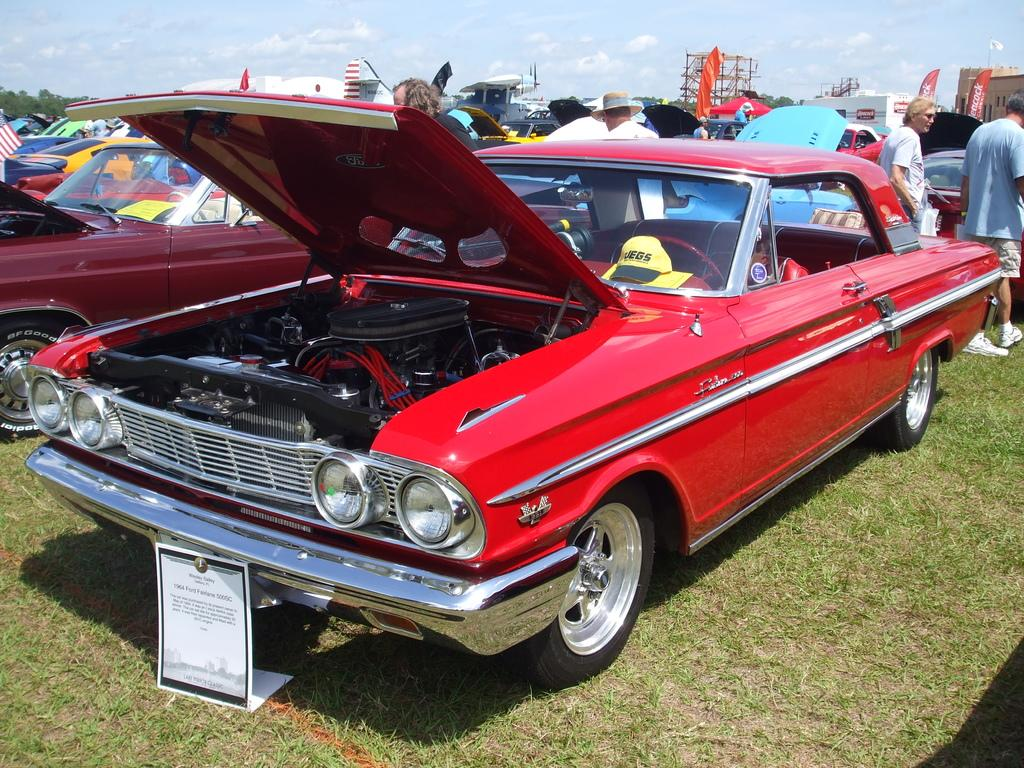What is the main subject of the image? The main subject of the image is many cars. What else can be seen in the image besides the cars? There is a board and many people in the background of the image. What is visible in the background of the image? There are trees and a cloudy sky in the background of the image. What type of quilt is being used to cover the crate in the image? There is no crate or quilt present in the image. 